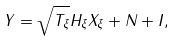Convert formula to latex. <formula><loc_0><loc_0><loc_500><loc_500>Y = \sqrt { T _ { \xi } } H _ { \xi } X _ { \xi } + N + I ,</formula> 